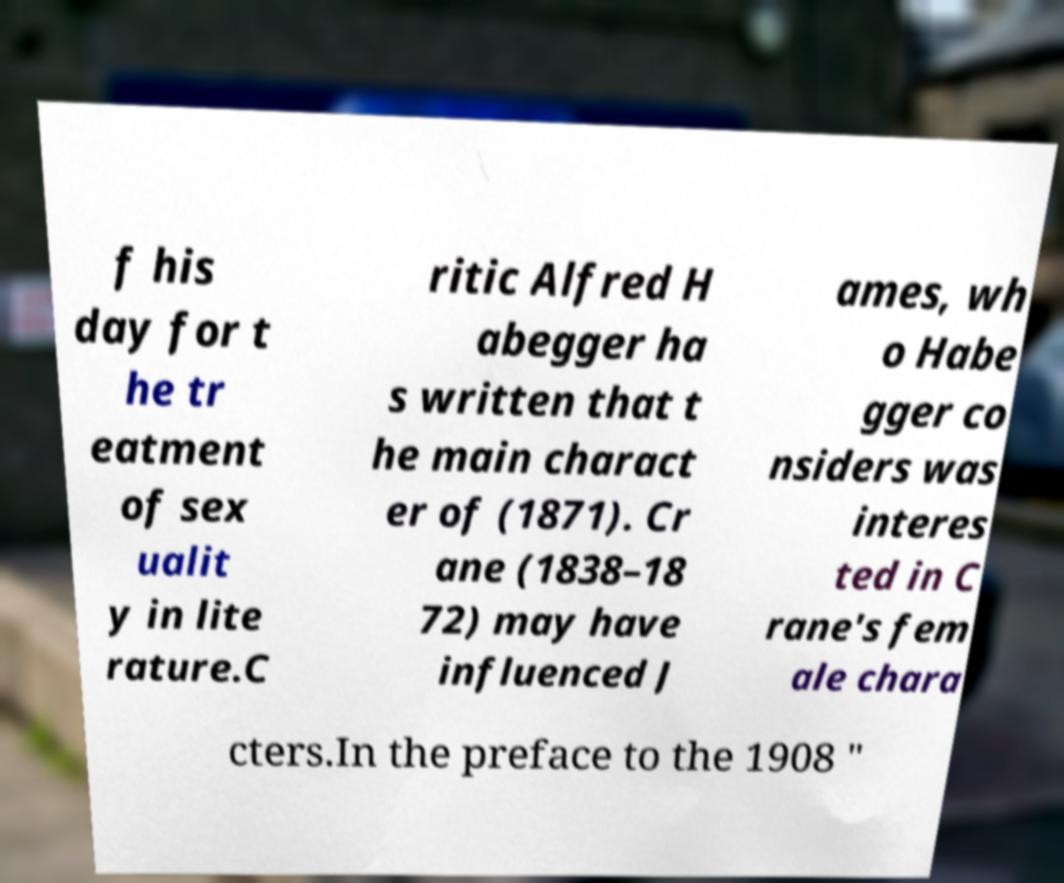Please read and relay the text visible in this image. What does it say? f his day for t he tr eatment of sex ualit y in lite rature.C ritic Alfred H abegger ha s written that t he main charact er of (1871). Cr ane (1838–18 72) may have influenced J ames, wh o Habe gger co nsiders was interes ted in C rane's fem ale chara cters.In the preface to the 1908 " 